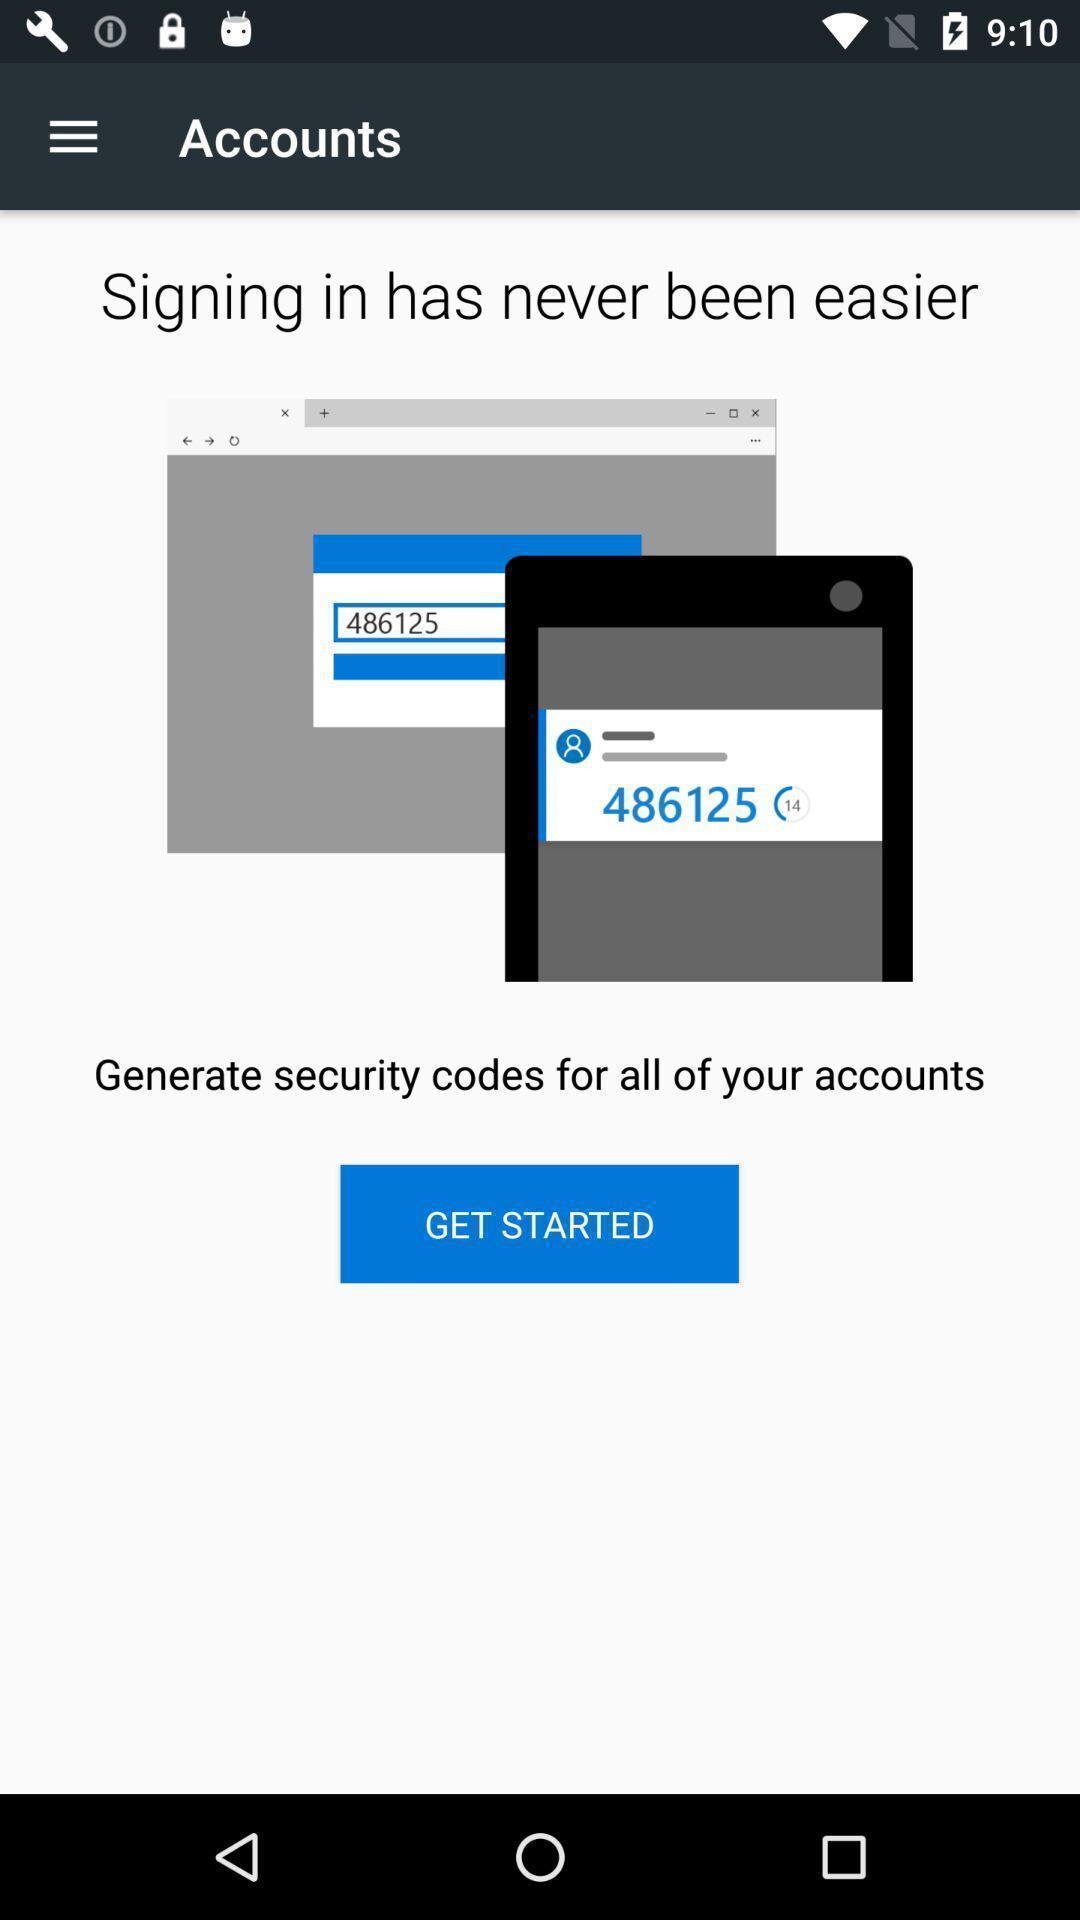Summarize the main components in this picture. Welcome page. 